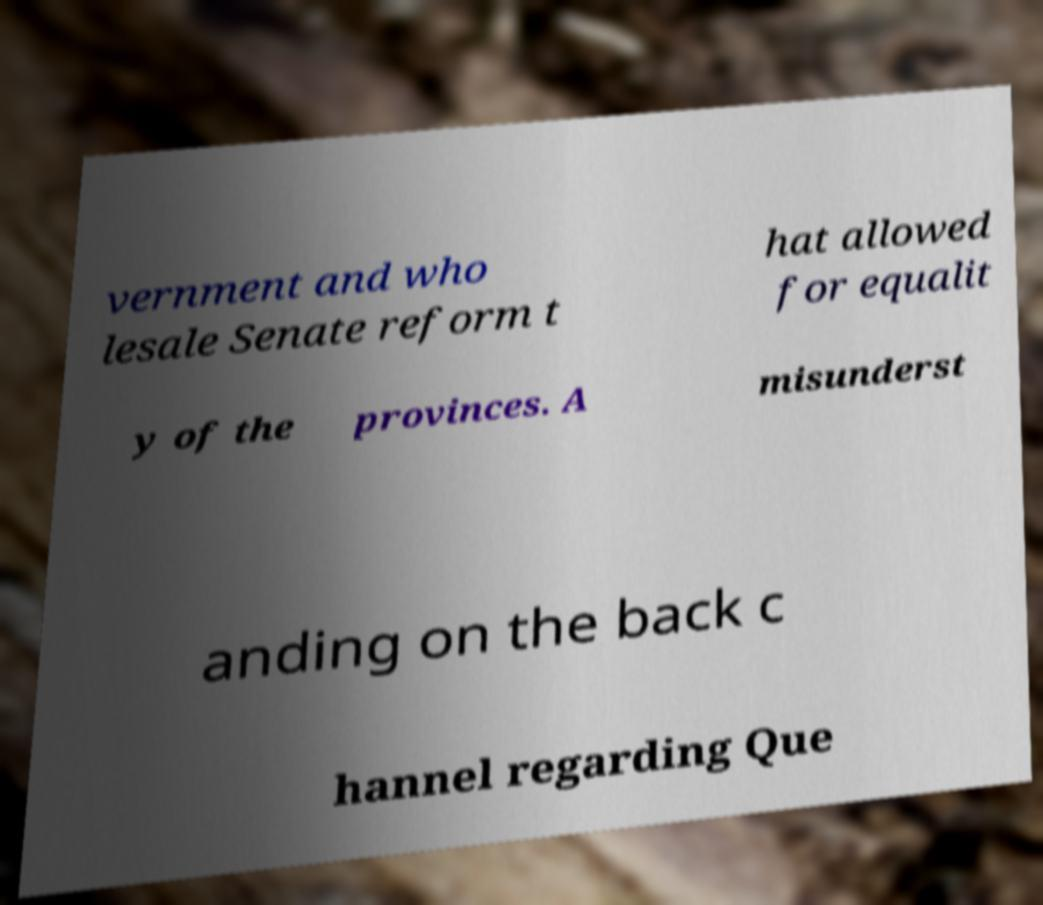What messages or text are displayed in this image? I need them in a readable, typed format. vernment and who lesale Senate reform t hat allowed for equalit y of the provinces. A misunderst anding on the back c hannel regarding Que 